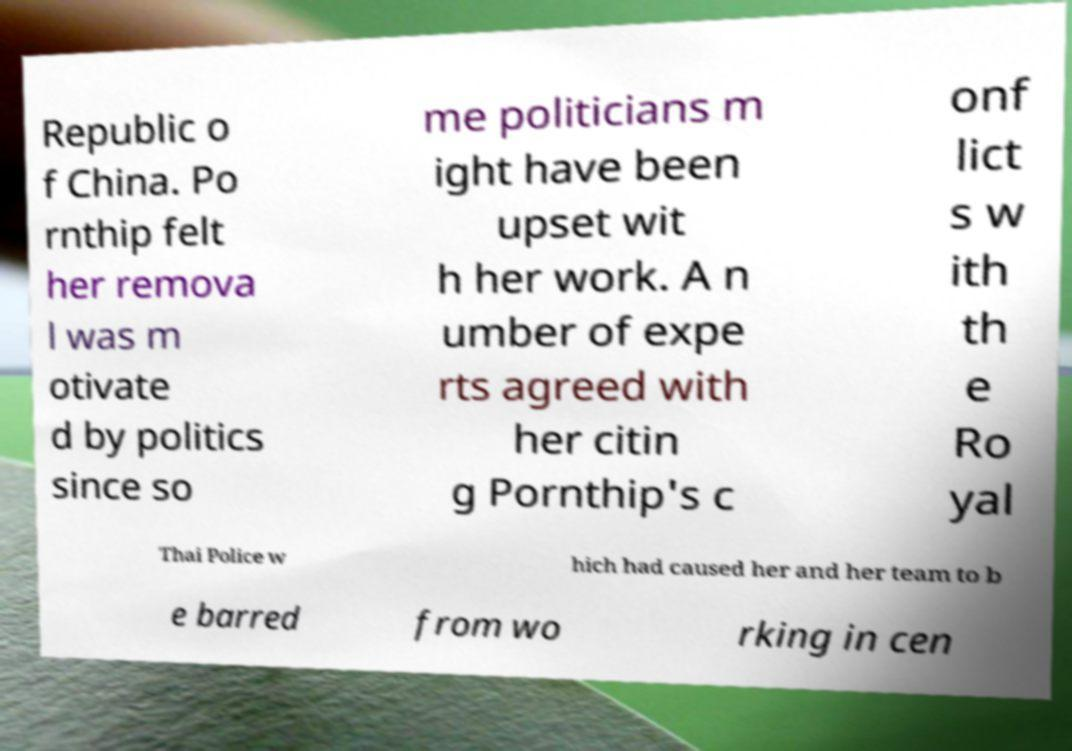Please read and relay the text visible in this image. What does it say? Republic o f China. Po rnthip felt her remova l was m otivate d by politics since so me politicians m ight have been upset wit h her work. A n umber of expe rts agreed with her citin g Pornthip's c onf lict s w ith th e Ro yal Thai Police w hich had caused her and her team to b e barred from wo rking in cen 